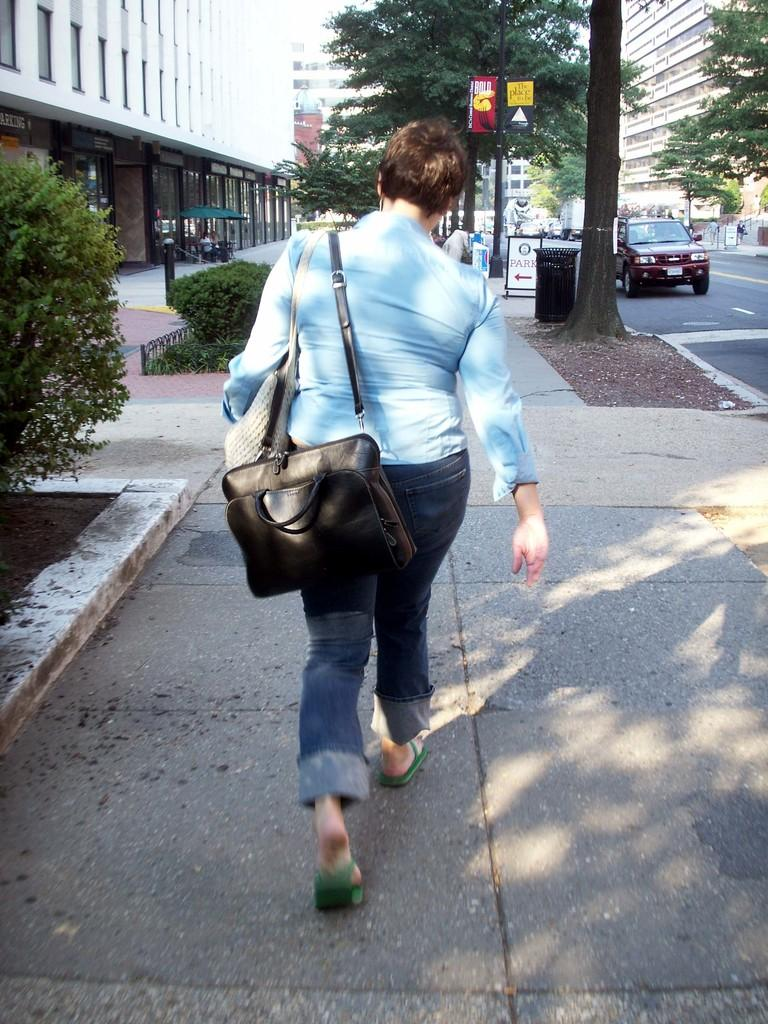What is the main subject of the image? The main subject of the image is a woman. What is the woman doing in the image? The woman is walking on a footpath in the image. Is the woman carrying anything while walking? Yes, the woman is carrying a bag. What type of muscle does the woman have in the image? There is no information about the woman's muscles in the image. What idea does the woman have in the image? There is no indication of any specific idea the woman might have in the image. 